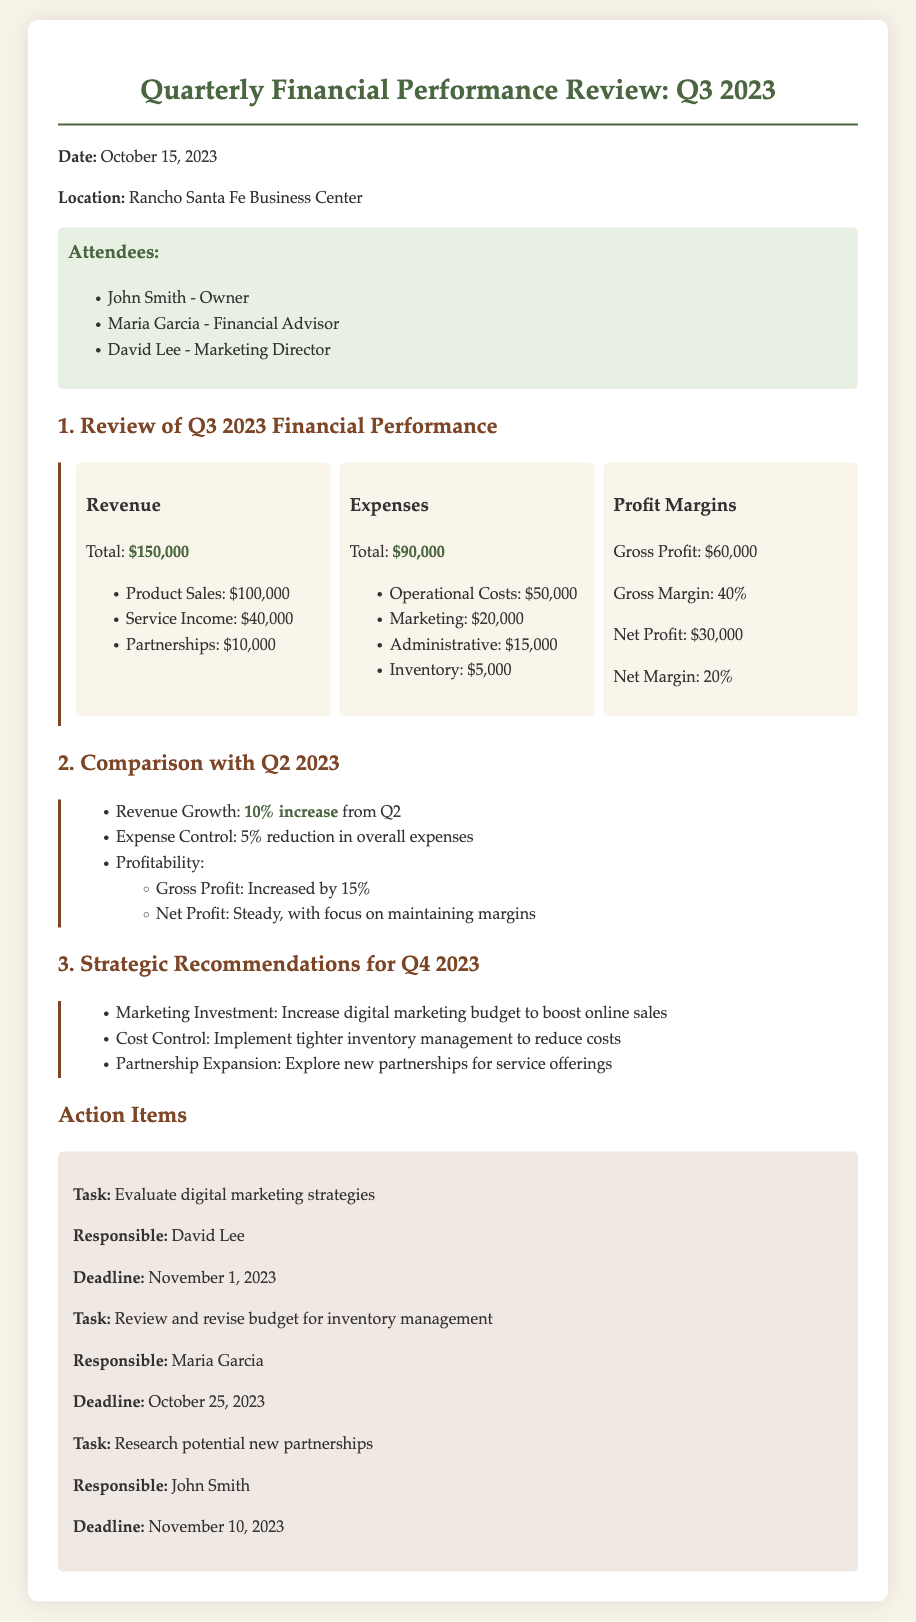What is the total revenue for Q3 2023? The total revenue is clearly stated in the document and is the sum of product sales, service income, and partnerships.
Answer: $150,000 What are the operational costs? Operational costs are listed under expenses in the document and refer specifically to one type of expense.
Answer: $50,000 What is the net profit for Q3 2023? The net profit is shown in the financial data section and represents the profit after all expenses have been deducted.
Answer: $30,000 What percentage did revenue grow from Q2 to Q3 2023? The document notes the specific increase in revenue percentage compared to the previous quarter.
Answer: 10% increase Who is responsible for evaluating digital marketing strategies? This person's name is mentioned beside the action item related to digital marketing.
Answer: David Lee What is the total amount spent on marketing in Q3 2023? This figure is provided in the breakdown of expenses and indicates a specific allocation of funds.
Answer: $20,000 Which action item needs to be completed by October 25, 2023? The document states the action items along with their respective deadlines.
Answer: Review and revise budget for inventory management What is the location of the meeting on October 15, 2023? The document specifies the venue for the meeting.
Answer: Rancho Santa Fe Business Center What is the gross margin for Q3 2023? The gross margin figure is included in the financial performance review section.
Answer: 40% 